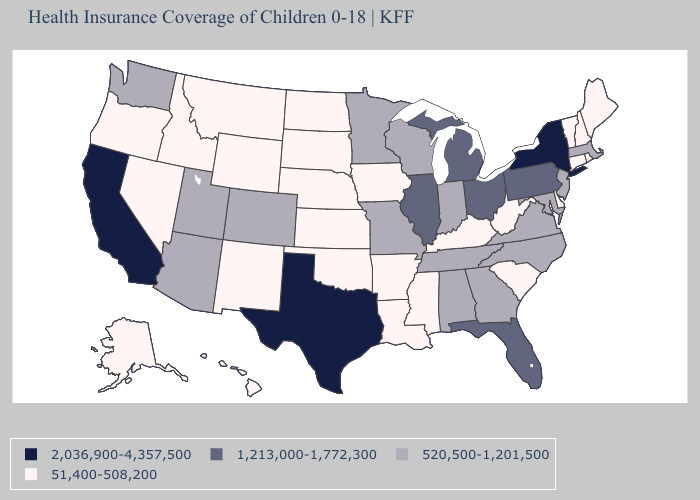Among the states that border Alabama , does Mississippi have the highest value?
Write a very short answer. No. Among the states that border Tennessee , does Arkansas have the lowest value?
Keep it brief. Yes. Is the legend a continuous bar?
Concise answer only. No. Name the states that have a value in the range 51,400-508,200?
Write a very short answer. Alaska, Arkansas, Connecticut, Delaware, Hawaii, Idaho, Iowa, Kansas, Kentucky, Louisiana, Maine, Mississippi, Montana, Nebraska, Nevada, New Hampshire, New Mexico, North Dakota, Oklahoma, Oregon, Rhode Island, South Carolina, South Dakota, Vermont, West Virginia, Wyoming. What is the highest value in states that border Tennessee?
Quick response, please. 520,500-1,201,500. Which states have the lowest value in the South?
Short answer required. Arkansas, Delaware, Kentucky, Louisiana, Mississippi, Oklahoma, South Carolina, West Virginia. What is the value of Maine?
Quick response, please. 51,400-508,200. Name the states that have a value in the range 2,036,900-4,357,500?
Quick response, please. California, New York, Texas. What is the value of New Hampshire?
Quick response, please. 51,400-508,200. What is the value of Ohio?
Answer briefly. 1,213,000-1,772,300. What is the highest value in the West ?
Write a very short answer. 2,036,900-4,357,500. Does the map have missing data?
Be succinct. No. Name the states that have a value in the range 1,213,000-1,772,300?
Answer briefly. Florida, Illinois, Michigan, Ohio, Pennsylvania. Name the states that have a value in the range 2,036,900-4,357,500?
Give a very brief answer. California, New York, Texas. What is the value of Mississippi?
Be succinct. 51,400-508,200. 